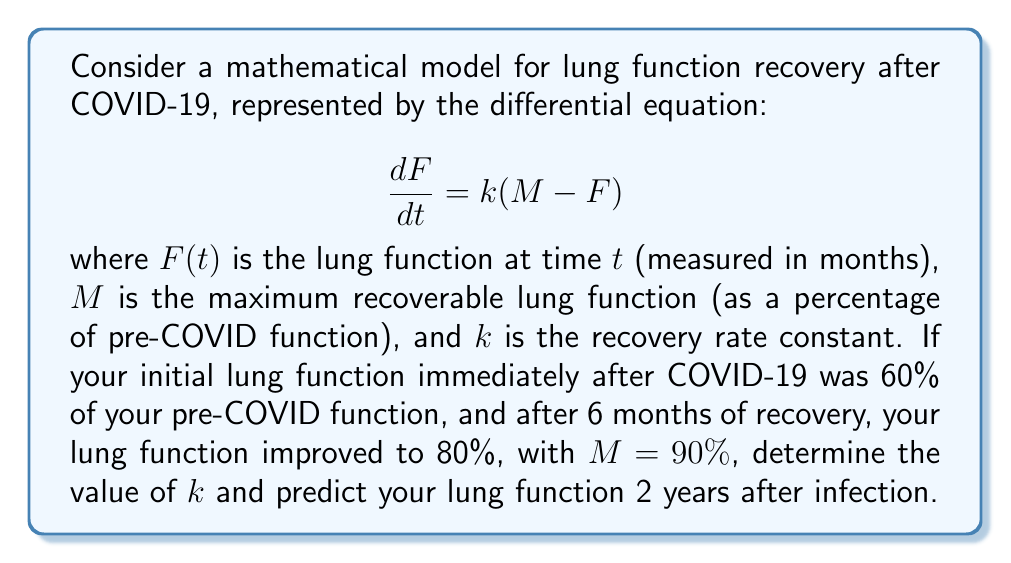Can you solve this math problem? To solve this problem, we'll follow these steps:

1) First, we need to solve the differential equation. The solution to this first-order linear differential equation is:

   $$F(t) = M - (M - F_0)e^{-kt}$$

   where $F_0$ is the initial lung function.

2) We're given that $F_0 = 60\%$, $M = 90\%$, and after 6 months ($t = 6$), $F(6) = 80\%$. Let's substitute these values:

   $$80 = 90 - (90 - 60)e^{-6k}$$

3) Simplify:
   $$80 = 90 - 30e^{-6k}$$
   $$10 = 30e^{-6k}$$
   $$\frac{1}{3} = e^{-6k}$$

4) Take natural log of both sides:
   $$\ln(\frac{1}{3}) = -6k$$
   $$-\ln(3) = -6k$$

5) Solve for $k$:
   $$k = \frac{\ln(3)}{6} \approx 0.1832$$

6) Now that we have $k$, we can predict lung function after 2 years (24 months):

   $$F(24) = 90 - (90 - 60)e^{-0.1832 * 24}$$
   $$F(24) = 90 - 30e^{-4.3968}$$
   $$F(24) = 90 - 30 * 0.0123$$
   $$F(24) = 89.63\%$$
Answer: The recovery rate constant $k$ is approximately 0.1832 per month. The predicted lung function 2 years after infection is approximately 89.63% of pre-COVID function. 